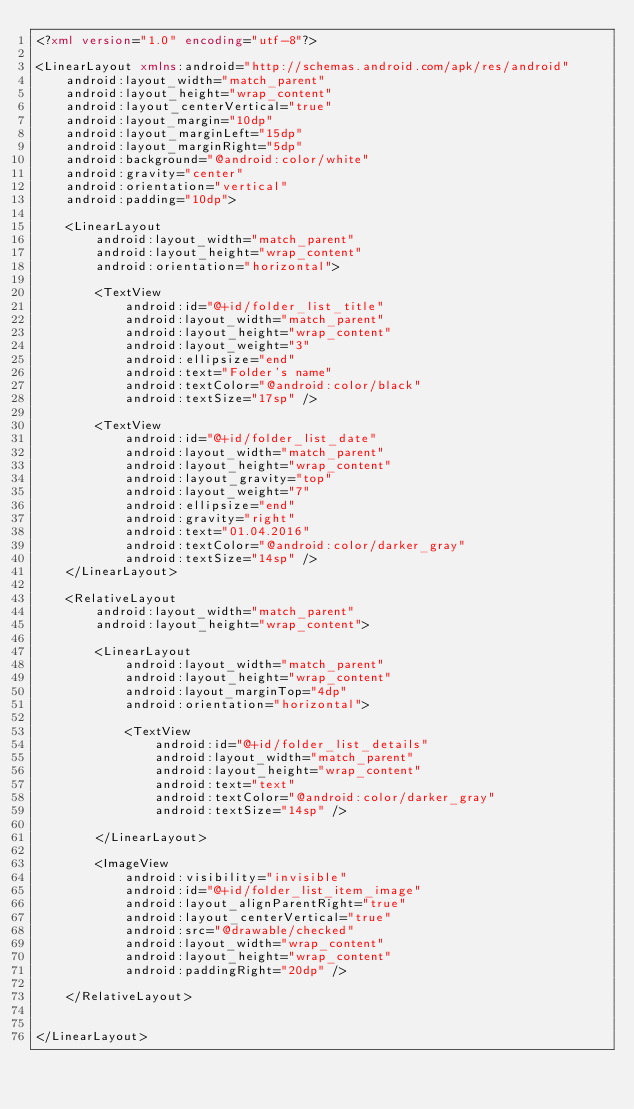Convert code to text. <code><loc_0><loc_0><loc_500><loc_500><_XML_><?xml version="1.0" encoding="utf-8"?>

<LinearLayout xmlns:android="http://schemas.android.com/apk/res/android"
    android:layout_width="match_parent"
    android:layout_height="wrap_content"
    android:layout_centerVertical="true"
    android:layout_margin="10dp"
    android:layout_marginLeft="15dp"
    android:layout_marginRight="5dp"
    android:background="@android:color/white"
    android:gravity="center"
    android:orientation="vertical"
    android:padding="10dp">

    <LinearLayout
        android:layout_width="match_parent"
        android:layout_height="wrap_content"
        android:orientation="horizontal">

        <TextView
            android:id="@+id/folder_list_title"
            android:layout_width="match_parent"
            android:layout_height="wrap_content"
            android:layout_weight="3"
            android:ellipsize="end"
            android:text="Folder's name"
            android:textColor="@android:color/black"
            android:textSize="17sp" />

        <TextView
            android:id="@+id/folder_list_date"
            android:layout_width="match_parent"
            android:layout_height="wrap_content"
            android:layout_gravity="top"
            android:layout_weight="7"
            android:ellipsize="end"
            android:gravity="right"
            android:text="01.04.2016"
            android:textColor="@android:color/darker_gray"
            android:textSize="14sp" />
    </LinearLayout>

    <RelativeLayout
        android:layout_width="match_parent"
        android:layout_height="wrap_content">

        <LinearLayout
            android:layout_width="match_parent"
            android:layout_height="wrap_content"
            android:layout_marginTop="4dp"
            android:orientation="horizontal">

            <TextView
                android:id="@+id/folder_list_details"
                android:layout_width="match_parent"
                android:layout_height="wrap_content"
                android:text="text"
                android:textColor="@android:color/darker_gray"
                android:textSize="14sp" />

        </LinearLayout>

        <ImageView
            android:visibility="invisible"
            android:id="@+id/folder_list_item_image"
            android:layout_alignParentRight="true"
            android:layout_centerVertical="true"
            android:src="@drawable/checked"
            android:layout_width="wrap_content"
            android:layout_height="wrap_content"
            android:paddingRight="20dp" />

    </RelativeLayout>


</LinearLayout>


</code> 